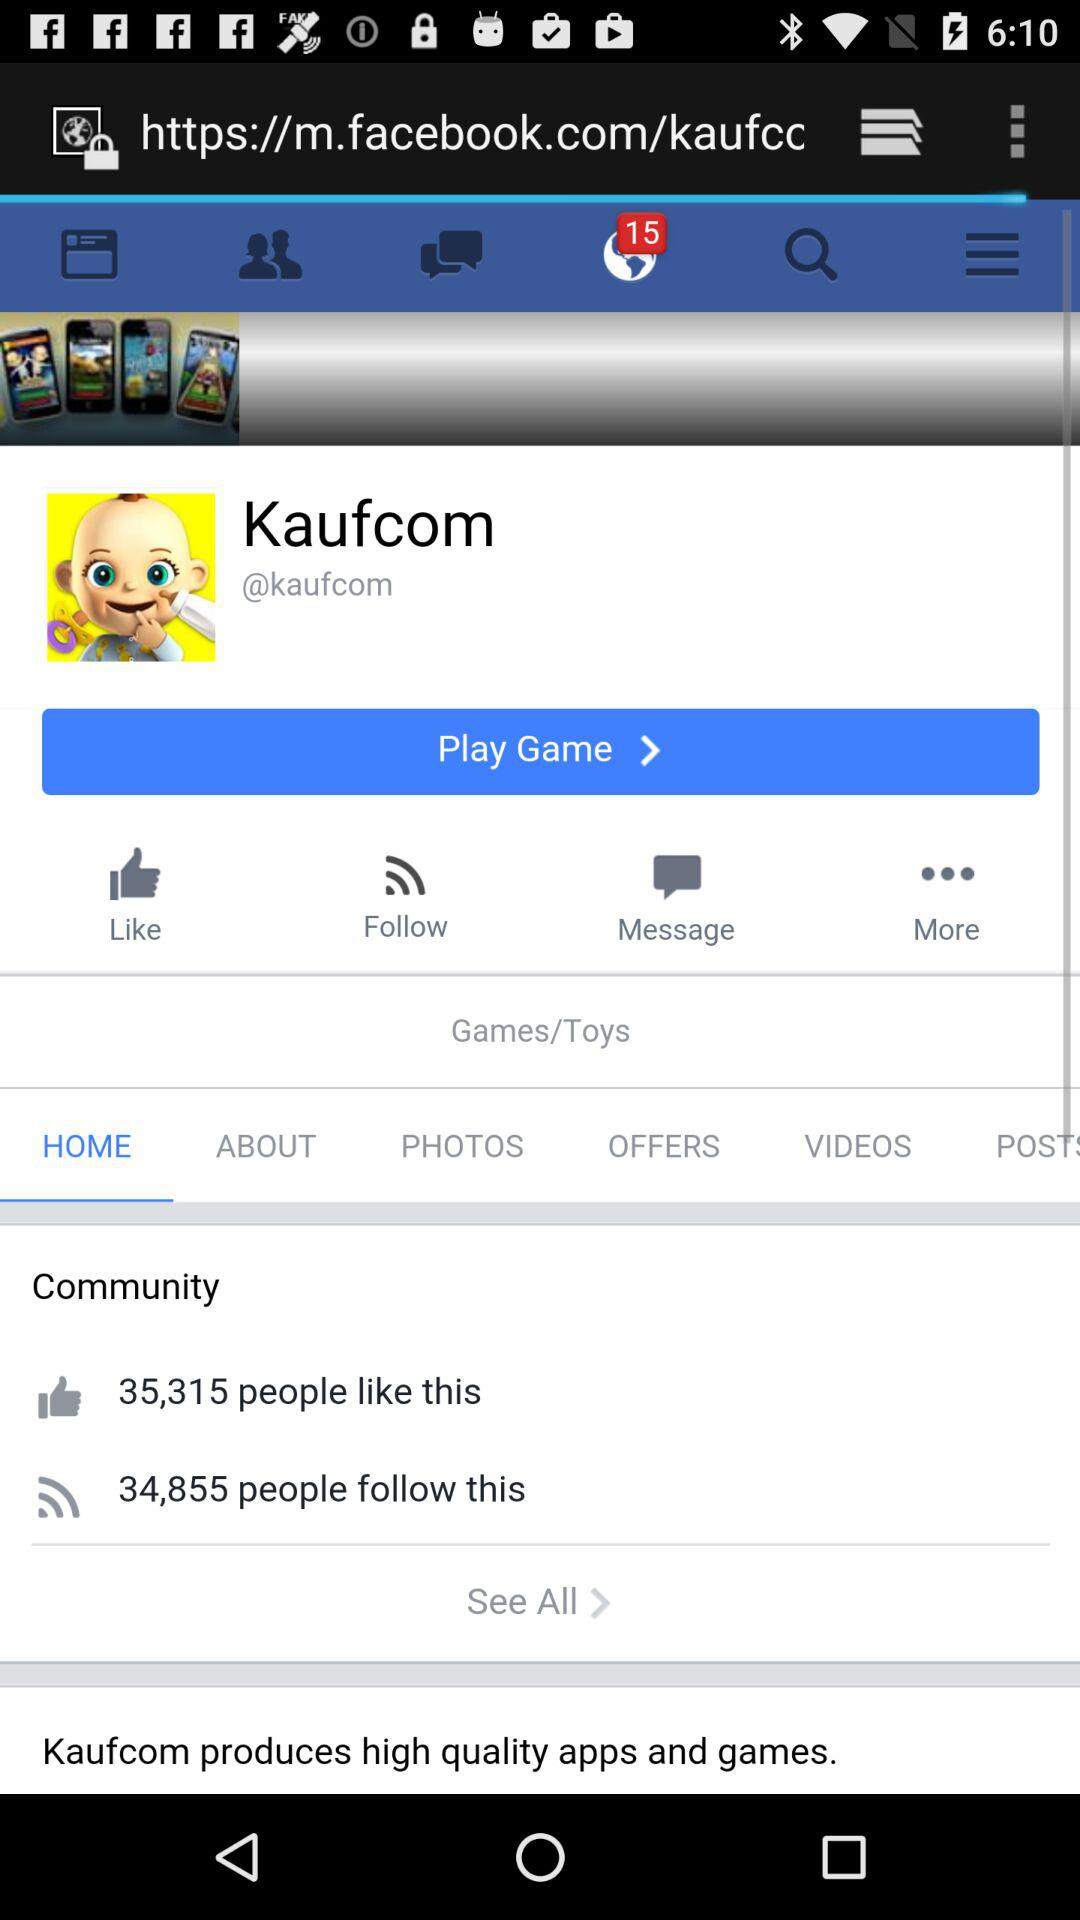How many photos are uploaded?
When the provided information is insufficient, respond with <no answer>. <no answer> 